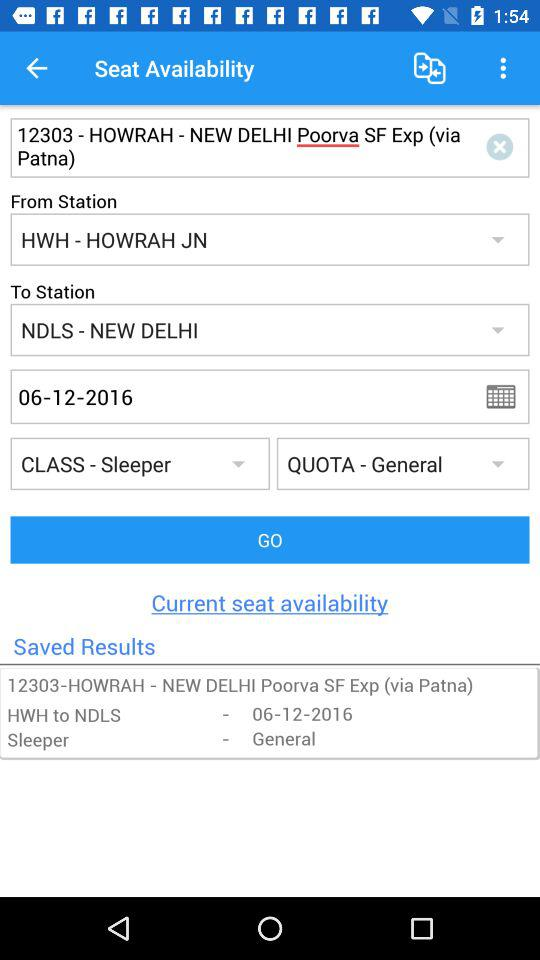What is the train number? The train number is 12303. 